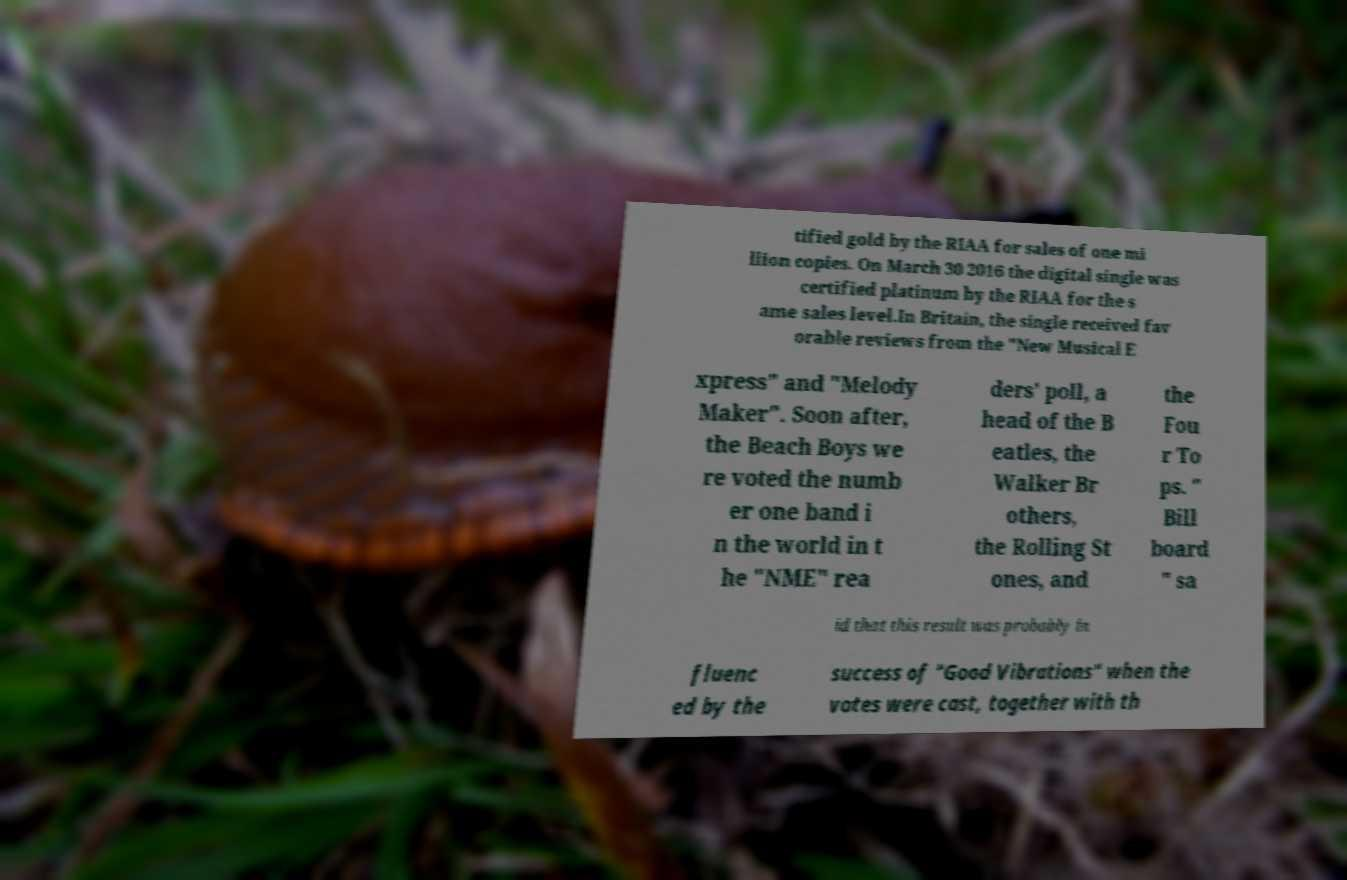Could you extract and type out the text from this image? tified gold by the RIAA for sales of one mi llion copies. On March 30 2016 the digital single was certified platinum by the RIAA for the s ame sales level.In Britain, the single received fav orable reviews from the "New Musical E xpress" and "Melody Maker". Soon after, the Beach Boys we re voted the numb er one band i n the world in t he "NME" rea ders' poll, a head of the B eatles, the Walker Br others, the Rolling St ones, and the Fou r To ps. " Bill board " sa id that this result was probably in fluenc ed by the success of "Good Vibrations" when the votes were cast, together with th 